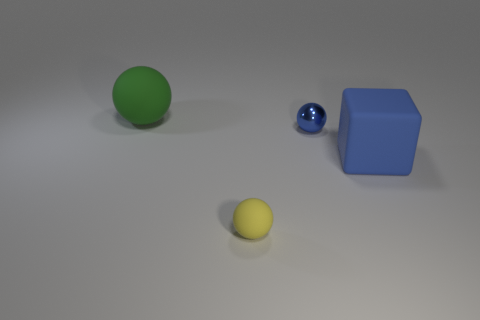Subtract 1 balls. How many balls are left? 2 Subtract all tiny balls. How many balls are left? 1 Add 4 big green things. How many objects exist? 8 Subtract all spheres. How many objects are left? 1 Subtract all purple things. Subtract all small balls. How many objects are left? 2 Add 3 yellow spheres. How many yellow spheres are left? 4 Add 4 small yellow matte balls. How many small yellow matte balls exist? 5 Subtract 1 blue balls. How many objects are left? 3 